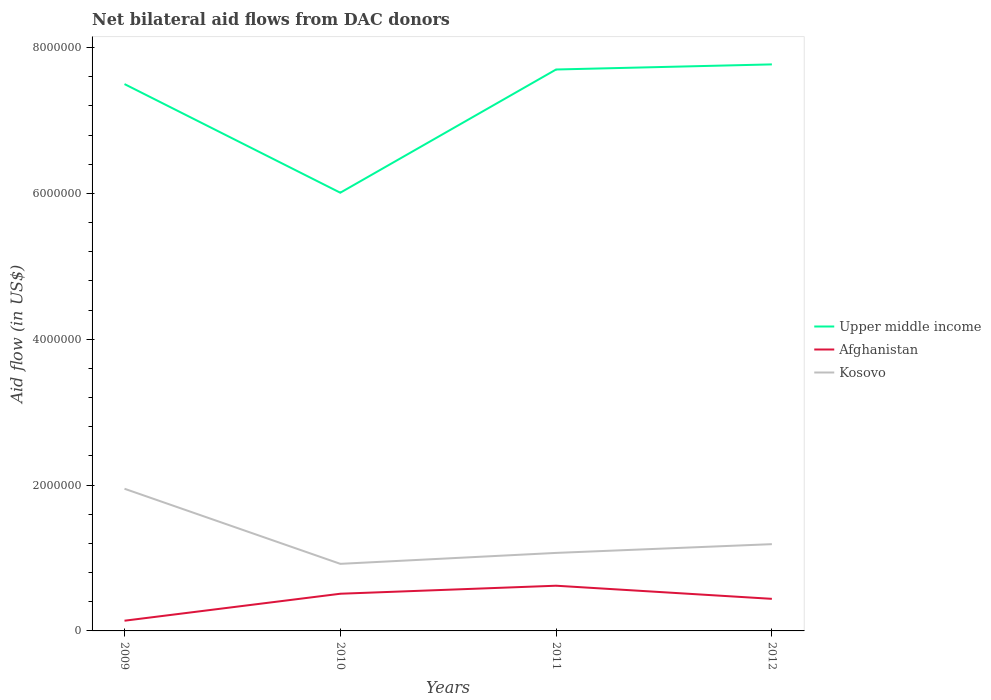How many different coloured lines are there?
Your response must be concise. 3. Does the line corresponding to Afghanistan intersect with the line corresponding to Upper middle income?
Give a very brief answer. No. Across all years, what is the maximum net bilateral aid flow in Upper middle income?
Your answer should be compact. 6.01e+06. In which year was the net bilateral aid flow in Afghanistan maximum?
Provide a succinct answer. 2009. What is the total net bilateral aid flow in Afghanistan in the graph?
Your answer should be very brief. -4.80e+05. What is the difference between the highest and the second highest net bilateral aid flow in Kosovo?
Provide a short and direct response. 1.03e+06. What is the difference between the highest and the lowest net bilateral aid flow in Afghanistan?
Your answer should be very brief. 3. Is the net bilateral aid flow in Kosovo strictly greater than the net bilateral aid flow in Afghanistan over the years?
Ensure brevity in your answer.  No. How many lines are there?
Make the answer very short. 3. How many years are there in the graph?
Provide a succinct answer. 4. Does the graph contain grids?
Provide a succinct answer. No. Where does the legend appear in the graph?
Provide a short and direct response. Center right. How many legend labels are there?
Keep it short and to the point. 3. How are the legend labels stacked?
Give a very brief answer. Vertical. What is the title of the graph?
Your answer should be very brief. Net bilateral aid flows from DAC donors. What is the label or title of the Y-axis?
Provide a succinct answer. Aid flow (in US$). What is the Aid flow (in US$) in Upper middle income in 2009?
Ensure brevity in your answer.  7.50e+06. What is the Aid flow (in US$) in Kosovo in 2009?
Offer a very short reply. 1.95e+06. What is the Aid flow (in US$) of Upper middle income in 2010?
Your answer should be compact. 6.01e+06. What is the Aid flow (in US$) of Afghanistan in 2010?
Your answer should be compact. 5.10e+05. What is the Aid flow (in US$) of Kosovo in 2010?
Make the answer very short. 9.20e+05. What is the Aid flow (in US$) of Upper middle income in 2011?
Your answer should be compact. 7.70e+06. What is the Aid flow (in US$) in Afghanistan in 2011?
Keep it short and to the point. 6.20e+05. What is the Aid flow (in US$) of Kosovo in 2011?
Your response must be concise. 1.07e+06. What is the Aid flow (in US$) of Upper middle income in 2012?
Ensure brevity in your answer.  7.77e+06. What is the Aid flow (in US$) in Kosovo in 2012?
Provide a succinct answer. 1.19e+06. Across all years, what is the maximum Aid flow (in US$) in Upper middle income?
Give a very brief answer. 7.77e+06. Across all years, what is the maximum Aid flow (in US$) in Afghanistan?
Ensure brevity in your answer.  6.20e+05. Across all years, what is the maximum Aid flow (in US$) of Kosovo?
Give a very brief answer. 1.95e+06. Across all years, what is the minimum Aid flow (in US$) of Upper middle income?
Provide a short and direct response. 6.01e+06. Across all years, what is the minimum Aid flow (in US$) of Kosovo?
Make the answer very short. 9.20e+05. What is the total Aid flow (in US$) of Upper middle income in the graph?
Ensure brevity in your answer.  2.90e+07. What is the total Aid flow (in US$) of Afghanistan in the graph?
Offer a very short reply. 1.71e+06. What is the total Aid flow (in US$) of Kosovo in the graph?
Your answer should be very brief. 5.13e+06. What is the difference between the Aid flow (in US$) in Upper middle income in 2009 and that in 2010?
Make the answer very short. 1.49e+06. What is the difference between the Aid flow (in US$) in Afghanistan in 2009 and that in 2010?
Offer a very short reply. -3.70e+05. What is the difference between the Aid flow (in US$) of Kosovo in 2009 and that in 2010?
Ensure brevity in your answer.  1.03e+06. What is the difference between the Aid flow (in US$) of Upper middle income in 2009 and that in 2011?
Keep it short and to the point. -2.00e+05. What is the difference between the Aid flow (in US$) in Afghanistan in 2009 and that in 2011?
Provide a short and direct response. -4.80e+05. What is the difference between the Aid flow (in US$) of Kosovo in 2009 and that in 2011?
Keep it short and to the point. 8.80e+05. What is the difference between the Aid flow (in US$) in Upper middle income in 2009 and that in 2012?
Ensure brevity in your answer.  -2.70e+05. What is the difference between the Aid flow (in US$) of Kosovo in 2009 and that in 2012?
Give a very brief answer. 7.60e+05. What is the difference between the Aid flow (in US$) of Upper middle income in 2010 and that in 2011?
Your response must be concise. -1.69e+06. What is the difference between the Aid flow (in US$) in Upper middle income in 2010 and that in 2012?
Your answer should be very brief. -1.76e+06. What is the difference between the Aid flow (in US$) in Afghanistan in 2010 and that in 2012?
Provide a short and direct response. 7.00e+04. What is the difference between the Aid flow (in US$) in Kosovo in 2010 and that in 2012?
Keep it short and to the point. -2.70e+05. What is the difference between the Aid flow (in US$) in Afghanistan in 2011 and that in 2012?
Ensure brevity in your answer.  1.80e+05. What is the difference between the Aid flow (in US$) of Kosovo in 2011 and that in 2012?
Ensure brevity in your answer.  -1.20e+05. What is the difference between the Aid flow (in US$) in Upper middle income in 2009 and the Aid flow (in US$) in Afghanistan in 2010?
Give a very brief answer. 6.99e+06. What is the difference between the Aid flow (in US$) in Upper middle income in 2009 and the Aid flow (in US$) in Kosovo in 2010?
Keep it short and to the point. 6.58e+06. What is the difference between the Aid flow (in US$) of Afghanistan in 2009 and the Aid flow (in US$) of Kosovo in 2010?
Your answer should be compact. -7.80e+05. What is the difference between the Aid flow (in US$) of Upper middle income in 2009 and the Aid flow (in US$) of Afghanistan in 2011?
Keep it short and to the point. 6.88e+06. What is the difference between the Aid flow (in US$) of Upper middle income in 2009 and the Aid flow (in US$) of Kosovo in 2011?
Provide a succinct answer. 6.43e+06. What is the difference between the Aid flow (in US$) in Afghanistan in 2009 and the Aid flow (in US$) in Kosovo in 2011?
Provide a short and direct response. -9.30e+05. What is the difference between the Aid flow (in US$) in Upper middle income in 2009 and the Aid flow (in US$) in Afghanistan in 2012?
Your response must be concise. 7.06e+06. What is the difference between the Aid flow (in US$) in Upper middle income in 2009 and the Aid flow (in US$) in Kosovo in 2012?
Make the answer very short. 6.31e+06. What is the difference between the Aid flow (in US$) in Afghanistan in 2009 and the Aid flow (in US$) in Kosovo in 2012?
Offer a terse response. -1.05e+06. What is the difference between the Aid flow (in US$) in Upper middle income in 2010 and the Aid flow (in US$) in Afghanistan in 2011?
Your answer should be compact. 5.39e+06. What is the difference between the Aid flow (in US$) in Upper middle income in 2010 and the Aid flow (in US$) in Kosovo in 2011?
Offer a very short reply. 4.94e+06. What is the difference between the Aid flow (in US$) in Afghanistan in 2010 and the Aid flow (in US$) in Kosovo in 2011?
Give a very brief answer. -5.60e+05. What is the difference between the Aid flow (in US$) of Upper middle income in 2010 and the Aid flow (in US$) of Afghanistan in 2012?
Make the answer very short. 5.57e+06. What is the difference between the Aid flow (in US$) in Upper middle income in 2010 and the Aid flow (in US$) in Kosovo in 2012?
Your response must be concise. 4.82e+06. What is the difference between the Aid flow (in US$) in Afghanistan in 2010 and the Aid flow (in US$) in Kosovo in 2012?
Make the answer very short. -6.80e+05. What is the difference between the Aid flow (in US$) in Upper middle income in 2011 and the Aid flow (in US$) in Afghanistan in 2012?
Ensure brevity in your answer.  7.26e+06. What is the difference between the Aid flow (in US$) in Upper middle income in 2011 and the Aid flow (in US$) in Kosovo in 2012?
Offer a terse response. 6.51e+06. What is the difference between the Aid flow (in US$) in Afghanistan in 2011 and the Aid flow (in US$) in Kosovo in 2012?
Ensure brevity in your answer.  -5.70e+05. What is the average Aid flow (in US$) in Upper middle income per year?
Give a very brief answer. 7.24e+06. What is the average Aid flow (in US$) in Afghanistan per year?
Your answer should be compact. 4.28e+05. What is the average Aid flow (in US$) of Kosovo per year?
Offer a very short reply. 1.28e+06. In the year 2009, what is the difference between the Aid flow (in US$) of Upper middle income and Aid flow (in US$) of Afghanistan?
Ensure brevity in your answer.  7.36e+06. In the year 2009, what is the difference between the Aid flow (in US$) in Upper middle income and Aid flow (in US$) in Kosovo?
Make the answer very short. 5.55e+06. In the year 2009, what is the difference between the Aid flow (in US$) of Afghanistan and Aid flow (in US$) of Kosovo?
Your answer should be very brief. -1.81e+06. In the year 2010, what is the difference between the Aid flow (in US$) of Upper middle income and Aid flow (in US$) of Afghanistan?
Ensure brevity in your answer.  5.50e+06. In the year 2010, what is the difference between the Aid flow (in US$) of Upper middle income and Aid flow (in US$) of Kosovo?
Your answer should be very brief. 5.09e+06. In the year 2010, what is the difference between the Aid flow (in US$) of Afghanistan and Aid flow (in US$) of Kosovo?
Ensure brevity in your answer.  -4.10e+05. In the year 2011, what is the difference between the Aid flow (in US$) in Upper middle income and Aid flow (in US$) in Afghanistan?
Make the answer very short. 7.08e+06. In the year 2011, what is the difference between the Aid flow (in US$) of Upper middle income and Aid flow (in US$) of Kosovo?
Your answer should be compact. 6.63e+06. In the year 2011, what is the difference between the Aid flow (in US$) of Afghanistan and Aid flow (in US$) of Kosovo?
Provide a succinct answer. -4.50e+05. In the year 2012, what is the difference between the Aid flow (in US$) in Upper middle income and Aid flow (in US$) in Afghanistan?
Your answer should be compact. 7.33e+06. In the year 2012, what is the difference between the Aid flow (in US$) of Upper middle income and Aid flow (in US$) of Kosovo?
Your response must be concise. 6.58e+06. In the year 2012, what is the difference between the Aid flow (in US$) in Afghanistan and Aid flow (in US$) in Kosovo?
Your response must be concise. -7.50e+05. What is the ratio of the Aid flow (in US$) of Upper middle income in 2009 to that in 2010?
Offer a very short reply. 1.25. What is the ratio of the Aid flow (in US$) in Afghanistan in 2009 to that in 2010?
Offer a terse response. 0.27. What is the ratio of the Aid flow (in US$) in Kosovo in 2009 to that in 2010?
Offer a very short reply. 2.12. What is the ratio of the Aid flow (in US$) in Upper middle income in 2009 to that in 2011?
Offer a very short reply. 0.97. What is the ratio of the Aid flow (in US$) of Afghanistan in 2009 to that in 2011?
Provide a short and direct response. 0.23. What is the ratio of the Aid flow (in US$) of Kosovo in 2009 to that in 2011?
Offer a terse response. 1.82. What is the ratio of the Aid flow (in US$) of Upper middle income in 2009 to that in 2012?
Make the answer very short. 0.97. What is the ratio of the Aid flow (in US$) of Afghanistan in 2009 to that in 2012?
Your answer should be compact. 0.32. What is the ratio of the Aid flow (in US$) of Kosovo in 2009 to that in 2012?
Keep it short and to the point. 1.64. What is the ratio of the Aid flow (in US$) of Upper middle income in 2010 to that in 2011?
Give a very brief answer. 0.78. What is the ratio of the Aid flow (in US$) in Afghanistan in 2010 to that in 2011?
Your answer should be very brief. 0.82. What is the ratio of the Aid flow (in US$) of Kosovo in 2010 to that in 2011?
Provide a succinct answer. 0.86. What is the ratio of the Aid flow (in US$) in Upper middle income in 2010 to that in 2012?
Provide a succinct answer. 0.77. What is the ratio of the Aid flow (in US$) of Afghanistan in 2010 to that in 2012?
Ensure brevity in your answer.  1.16. What is the ratio of the Aid flow (in US$) of Kosovo in 2010 to that in 2012?
Make the answer very short. 0.77. What is the ratio of the Aid flow (in US$) in Afghanistan in 2011 to that in 2012?
Offer a very short reply. 1.41. What is the ratio of the Aid flow (in US$) of Kosovo in 2011 to that in 2012?
Make the answer very short. 0.9. What is the difference between the highest and the second highest Aid flow (in US$) of Upper middle income?
Your answer should be compact. 7.00e+04. What is the difference between the highest and the second highest Aid flow (in US$) of Afghanistan?
Provide a short and direct response. 1.10e+05. What is the difference between the highest and the second highest Aid flow (in US$) of Kosovo?
Make the answer very short. 7.60e+05. What is the difference between the highest and the lowest Aid flow (in US$) in Upper middle income?
Your answer should be compact. 1.76e+06. What is the difference between the highest and the lowest Aid flow (in US$) in Afghanistan?
Give a very brief answer. 4.80e+05. What is the difference between the highest and the lowest Aid flow (in US$) in Kosovo?
Provide a succinct answer. 1.03e+06. 